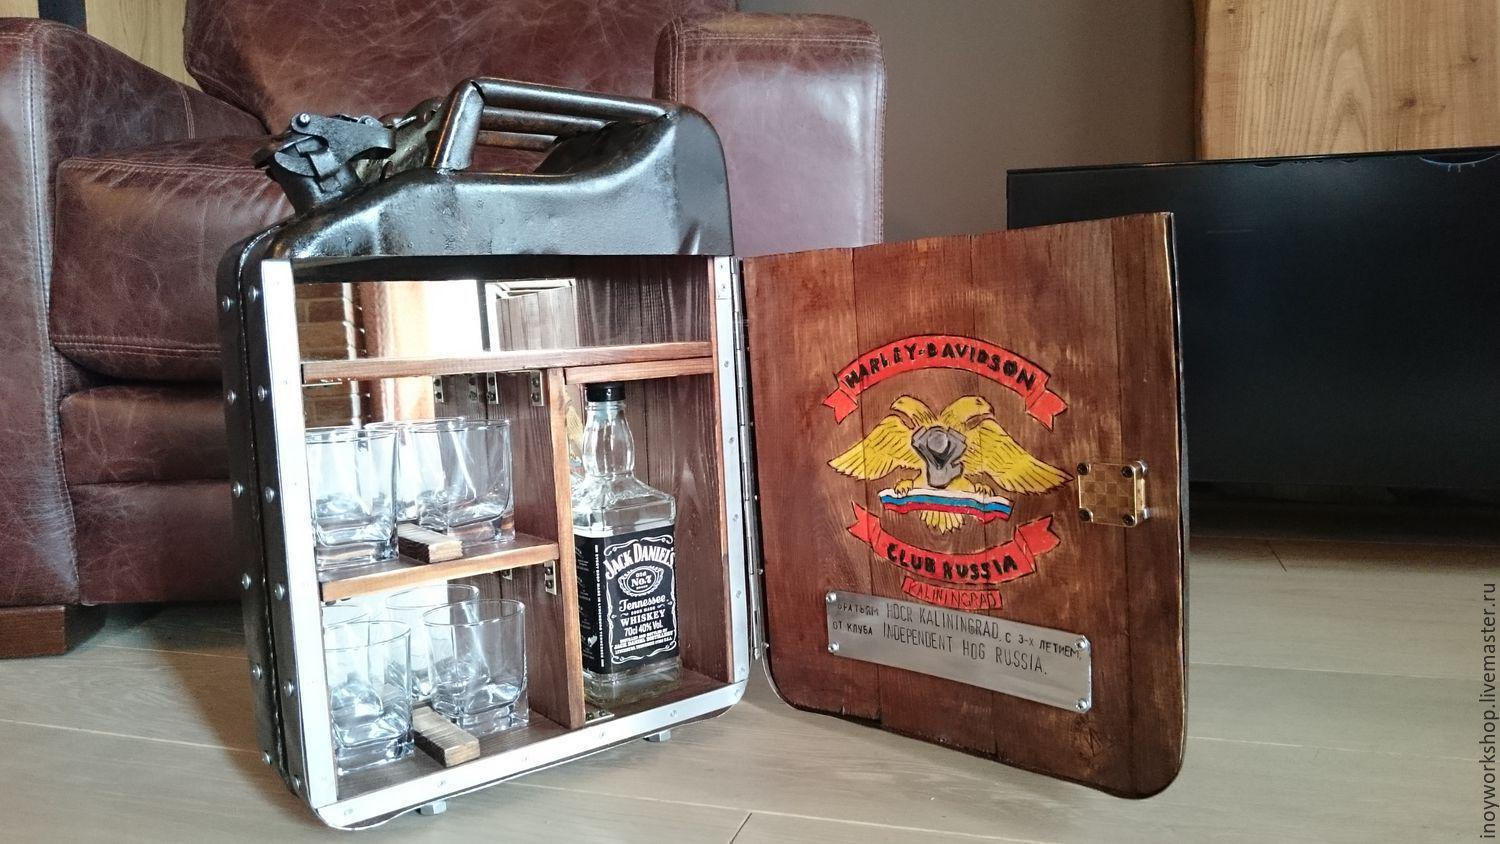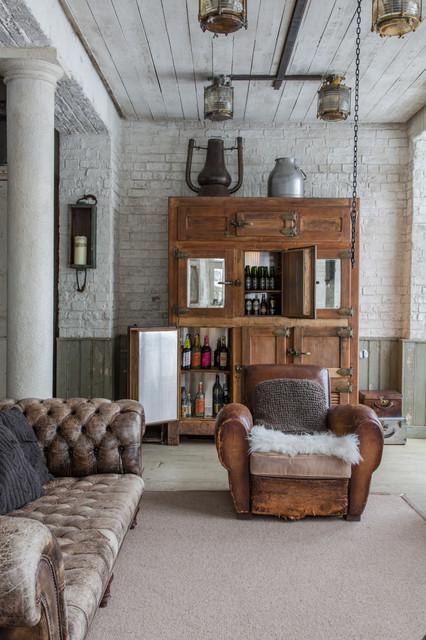The first image is the image on the left, the second image is the image on the right. For the images displayed, is the sentence "At least one wine bottle is being stored horizontally in a rack." factually correct? Answer yes or no. No. The first image is the image on the left, the second image is the image on the right. Assess this claim about the two images: "In at least one image there is a brown chair next to a homemade bar.". Correct or not? Answer yes or no. Yes. 